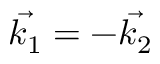<formula> <loc_0><loc_0><loc_500><loc_500>\vec { k _ { 1 } } = - \vec { k _ { 2 } }</formula> 